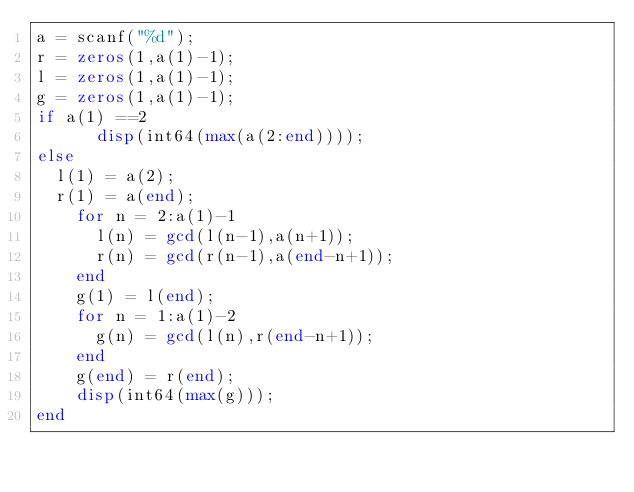Convert code to text. <code><loc_0><loc_0><loc_500><loc_500><_Octave_>a = scanf("%d");
r = zeros(1,a(1)-1);
l = zeros(1,a(1)-1);
g = zeros(1,a(1)-1);
if a(1) ==2
	  disp(int64(max(a(2:end))));
else
  l(1) = a(2);
  r(1) = a(end);
  	for n = 2:a(1)-1
      l(n) = gcd(l(n-1),a(n+1));
      r(n) = gcd(r(n-1),a(end-n+1));
  	end
    g(1) = l(end);
  	for n = 1:a(1)-2
      g(n) = gcd(l(n),r(end-n+1));
    end
    g(end) = r(end);
  	disp(int64(max(g)));
end
</code> 